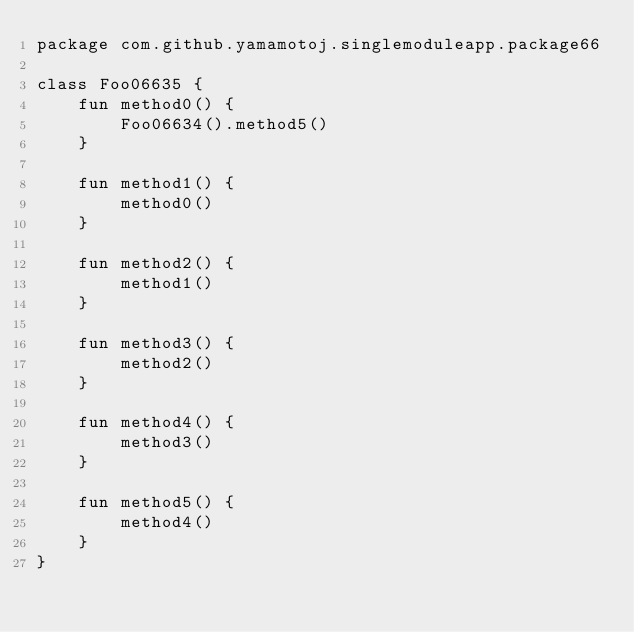Convert code to text. <code><loc_0><loc_0><loc_500><loc_500><_Kotlin_>package com.github.yamamotoj.singlemoduleapp.package66

class Foo06635 {
    fun method0() {
        Foo06634().method5()
    }

    fun method1() {
        method0()
    }

    fun method2() {
        method1()
    }

    fun method3() {
        method2()
    }

    fun method4() {
        method3()
    }

    fun method5() {
        method4()
    }
}
</code> 